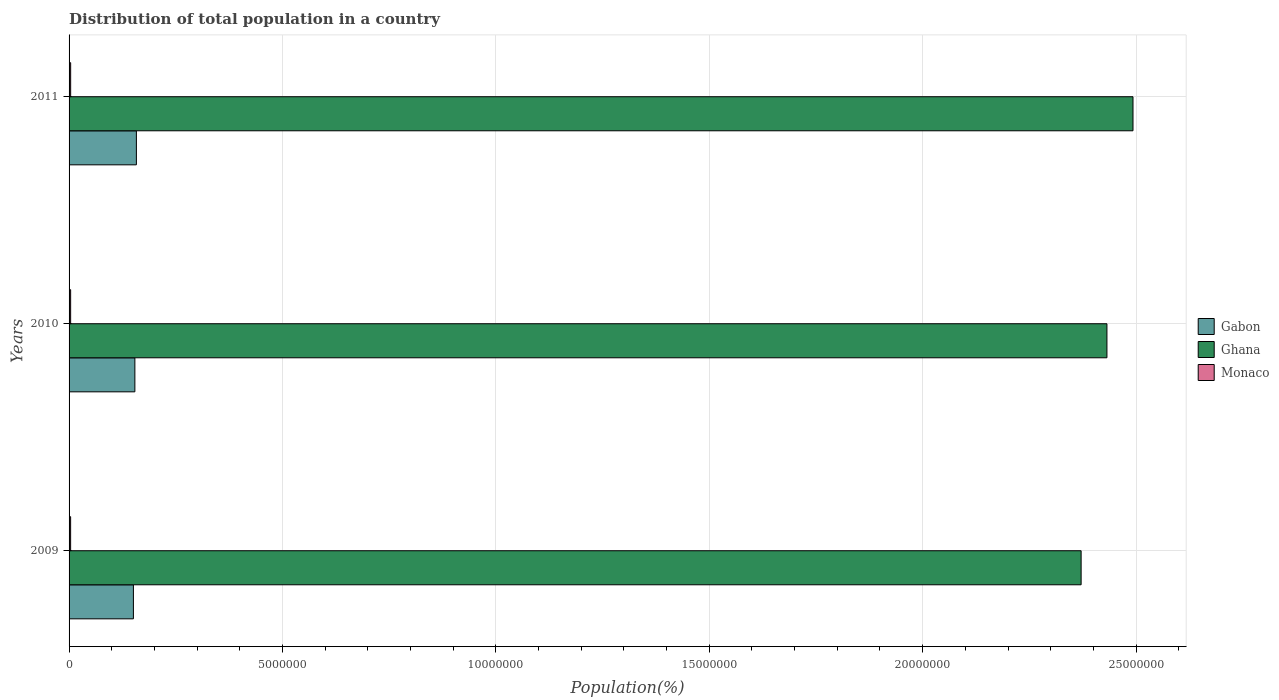How many groups of bars are there?
Offer a very short reply. 3. Are the number of bars on each tick of the Y-axis equal?
Provide a short and direct response. Yes. How many bars are there on the 3rd tick from the bottom?
Give a very brief answer. 3. In how many cases, is the number of bars for a given year not equal to the number of legend labels?
Ensure brevity in your answer.  0. What is the population of in Monaco in 2009?
Keep it short and to the point. 3.64e+04. Across all years, what is the maximum population of in Monaco?
Keep it short and to the point. 3.72e+04. Across all years, what is the minimum population of in Gabon?
Provide a succinct answer. 1.51e+06. What is the total population of in Monaco in the graph?
Offer a terse response. 1.10e+05. What is the difference between the population of in Gabon in 2010 and that in 2011?
Your response must be concise. -3.54e+04. What is the difference between the population of in Ghana in 2009 and the population of in Gabon in 2011?
Your answer should be compact. 2.21e+07. What is the average population of in Ghana per year?
Offer a terse response. 2.43e+07. In the year 2011, what is the difference between the population of in Gabon and population of in Ghana?
Ensure brevity in your answer.  -2.34e+07. In how many years, is the population of in Ghana greater than 13000000 %?
Offer a very short reply. 3. What is the ratio of the population of in Monaco in 2010 to that in 2011?
Your answer should be compact. 0.99. Is the difference between the population of in Gabon in 2010 and 2011 greater than the difference between the population of in Ghana in 2010 and 2011?
Make the answer very short. Yes. What is the difference between the highest and the second highest population of in Ghana?
Offer a very short reply. 6.11e+05. What is the difference between the highest and the lowest population of in Ghana?
Make the answer very short. 1.22e+06. What does the 1st bar from the top in 2010 represents?
Your answer should be compact. Monaco. What does the 1st bar from the bottom in 2009 represents?
Keep it short and to the point. Gabon. Is it the case that in every year, the sum of the population of in Gabon and population of in Monaco is greater than the population of in Ghana?
Offer a terse response. No. How many bars are there?
Offer a terse response. 9. Are all the bars in the graph horizontal?
Keep it short and to the point. Yes. What is the difference between two consecutive major ticks on the X-axis?
Offer a terse response. 5.00e+06. Does the graph contain any zero values?
Your response must be concise. No. What is the title of the graph?
Your answer should be compact. Distribution of total population in a country. What is the label or title of the X-axis?
Offer a terse response. Population(%). What is the label or title of the Y-axis?
Your answer should be compact. Years. What is the Population(%) of Gabon in 2009?
Give a very brief answer. 1.51e+06. What is the Population(%) in Ghana in 2009?
Provide a short and direct response. 2.37e+07. What is the Population(%) of Monaco in 2009?
Offer a very short reply. 3.64e+04. What is the Population(%) in Gabon in 2010?
Make the answer very short. 1.54e+06. What is the Population(%) of Ghana in 2010?
Ensure brevity in your answer.  2.43e+07. What is the Population(%) in Monaco in 2010?
Provide a succinct answer. 3.68e+04. What is the Population(%) of Gabon in 2011?
Ensure brevity in your answer.  1.58e+06. What is the Population(%) in Ghana in 2011?
Your answer should be compact. 2.49e+07. What is the Population(%) in Monaco in 2011?
Provide a short and direct response. 3.72e+04. Across all years, what is the maximum Population(%) in Gabon?
Offer a very short reply. 1.58e+06. Across all years, what is the maximum Population(%) of Ghana?
Offer a very short reply. 2.49e+07. Across all years, what is the maximum Population(%) of Monaco?
Make the answer very short. 3.72e+04. Across all years, what is the minimum Population(%) in Gabon?
Give a very brief answer. 1.51e+06. Across all years, what is the minimum Population(%) of Ghana?
Provide a short and direct response. 2.37e+07. Across all years, what is the minimum Population(%) in Monaco?
Your answer should be compact. 3.64e+04. What is the total Population(%) of Gabon in the graph?
Keep it short and to the point. 4.63e+06. What is the total Population(%) in Ghana in the graph?
Your answer should be very brief. 7.30e+07. What is the total Population(%) of Monaco in the graph?
Make the answer very short. 1.10e+05. What is the difference between the Population(%) of Gabon in 2009 and that in 2010?
Provide a short and direct response. -3.45e+04. What is the difference between the Population(%) of Ghana in 2009 and that in 2010?
Make the answer very short. -6.05e+05. What is the difference between the Population(%) of Monaco in 2009 and that in 2010?
Provide a succinct answer. -494. What is the difference between the Population(%) of Gabon in 2009 and that in 2011?
Offer a very short reply. -6.99e+04. What is the difference between the Population(%) of Ghana in 2009 and that in 2011?
Your response must be concise. -1.22e+06. What is the difference between the Population(%) of Monaco in 2009 and that in 2011?
Give a very brief answer. -838. What is the difference between the Population(%) of Gabon in 2010 and that in 2011?
Provide a succinct answer. -3.54e+04. What is the difference between the Population(%) in Ghana in 2010 and that in 2011?
Offer a terse response. -6.11e+05. What is the difference between the Population(%) in Monaco in 2010 and that in 2011?
Provide a succinct answer. -344. What is the difference between the Population(%) in Gabon in 2009 and the Population(%) in Ghana in 2010?
Your response must be concise. -2.28e+07. What is the difference between the Population(%) in Gabon in 2009 and the Population(%) in Monaco in 2010?
Your answer should be very brief. 1.47e+06. What is the difference between the Population(%) in Ghana in 2009 and the Population(%) in Monaco in 2010?
Your answer should be very brief. 2.37e+07. What is the difference between the Population(%) in Gabon in 2009 and the Population(%) in Ghana in 2011?
Make the answer very short. -2.34e+07. What is the difference between the Population(%) of Gabon in 2009 and the Population(%) of Monaco in 2011?
Ensure brevity in your answer.  1.47e+06. What is the difference between the Population(%) in Ghana in 2009 and the Population(%) in Monaco in 2011?
Ensure brevity in your answer.  2.37e+07. What is the difference between the Population(%) in Gabon in 2010 and the Population(%) in Ghana in 2011?
Your response must be concise. -2.34e+07. What is the difference between the Population(%) in Gabon in 2010 and the Population(%) in Monaco in 2011?
Offer a very short reply. 1.50e+06. What is the difference between the Population(%) in Ghana in 2010 and the Population(%) in Monaco in 2011?
Your response must be concise. 2.43e+07. What is the average Population(%) in Gabon per year?
Your answer should be compact. 1.54e+06. What is the average Population(%) of Ghana per year?
Make the answer very short. 2.43e+07. What is the average Population(%) of Monaco per year?
Offer a terse response. 3.68e+04. In the year 2009, what is the difference between the Population(%) in Gabon and Population(%) in Ghana?
Make the answer very short. -2.22e+07. In the year 2009, what is the difference between the Population(%) of Gabon and Population(%) of Monaco?
Offer a very short reply. 1.47e+06. In the year 2009, what is the difference between the Population(%) in Ghana and Population(%) in Monaco?
Your answer should be very brief. 2.37e+07. In the year 2010, what is the difference between the Population(%) of Gabon and Population(%) of Ghana?
Provide a succinct answer. -2.28e+07. In the year 2010, what is the difference between the Population(%) in Gabon and Population(%) in Monaco?
Keep it short and to the point. 1.51e+06. In the year 2010, what is the difference between the Population(%) in Ghana and Population(%) in Monaco?
Keep it short and to the point. 2.43e+07. In the year 2011, what is the difference between the Population(%) of Gabon and Population(%) of Ghana?
Give a very brief answer. -2.34e+07. In the year 2011, what is the difference between the Population(%) of Gabon and Population(%) of Monaco?
Your answer should be compact. 1.54e+06. In the year 2011, what is the difference between the Population(%) of Ghana and Population(%) of Monaco?
Give a very brief answer. 2.49e+07. What is the ratio of the Population(%) in Gabon in 2009 to that in 2010?
Your answer should be very brief. 0.98. What is the ratio of the Population(%) of Ghana in 2009 to that in 2010?
Provide a short and direct response. 0.98. What is the ratio of the Population(%) in Monaco in 2009 to that in 2010?
Offer a terse response. 0.99. What is the ratio of the Population(%) of Gabon in 2009 to that in 2011?
Your answer should be compact. 0.96. What is the ratio of the Population(%) of Ghana in 2009 to that in 2011?
Provide a succinct answer. 0.95. What is the ratio of the Population(%) of Monaco in 2009 to that in 2011?
Your answer should be very brief. 0.98. What is the ratio of the Population(%) in Gabon in 2010 to that in 2011?
Offer a terse response. 0.98. What is the ratio of the Population(%) of Ghana in 2010 to that in 2011?
Keep it short and to the point. 0.98. What is the ratio of the Population(%) of Monaco in 2010 to that in 2011?
Offer a very short reply. 0.99. What is the difference between the highest and the second highest Population(%) in Gabon?
Provide a succinct answer. 3.54e+04. What is the difference between the highest and the second highest Population(%) of Ghana?
Make the answer very short. 6.11e+05. What is the difference between the highest and the second highest Population(%) in Monaco?
Give a very brief answer. 344. What is the difference between the highest and the lowest Population(%) in Gabon?
Your answer should be compact. 6.99e+04. What is the difference between the highest and the lowest Population(%) in Ghana?
Make the answer very short. 1.22e+06. What is the difference between the highest and the lowest Population(%) of Monaco?
Your answer should be compact. 838. 